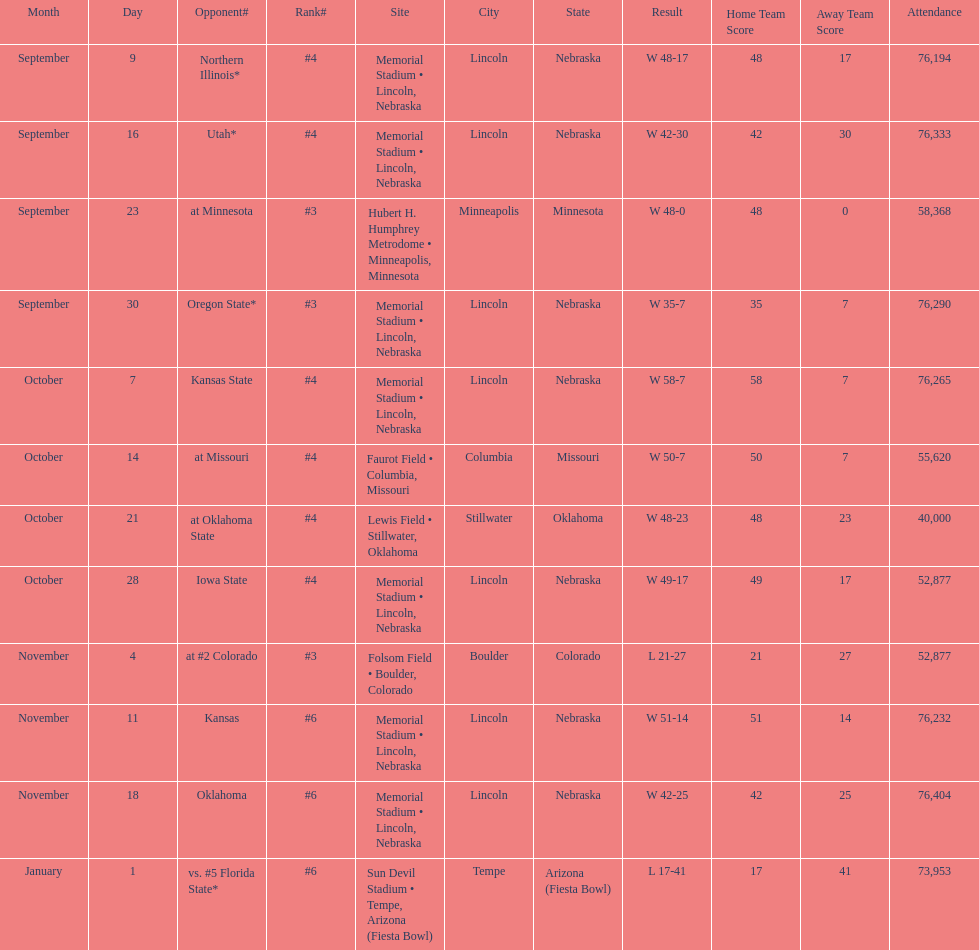On average how many times was w listed as the result? 10. 